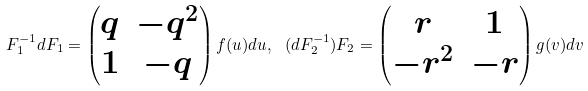<formula> <loc_0><loc_0><loc_500><loc_500>F _ { 1 } ^ { - 1 } d F _ { 1 } = \begin{pmatrix} q & - q ^ { 2 } \\ 1 & - q \end{pmatrix} f ( u ) d u , \ ( d F _ { 2 } ^ { - 1 } ) F _ { 2 } = \begin{pmatrix} r & 1 \\ - r ^ { 2 } & - r \end{pmatrix} g ( v ) d v</formula> 